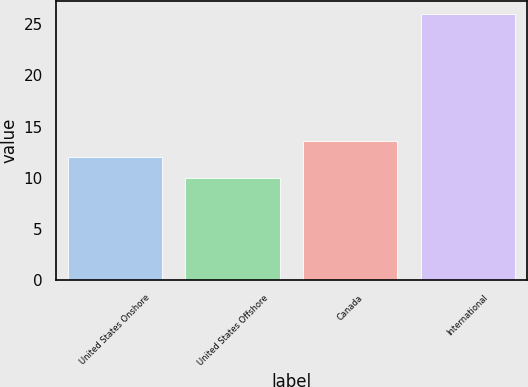Convert chart to OTSL. <chart><loc_0><loc_0><loc_500><loc_500><bar_chart><fcel>United States Onshore<fcel>United States Offshore<fcel>Canada<fcel>International<nl><fcel>12<fcel>10<fcel>13.6<fcel>26<nl></chart> 